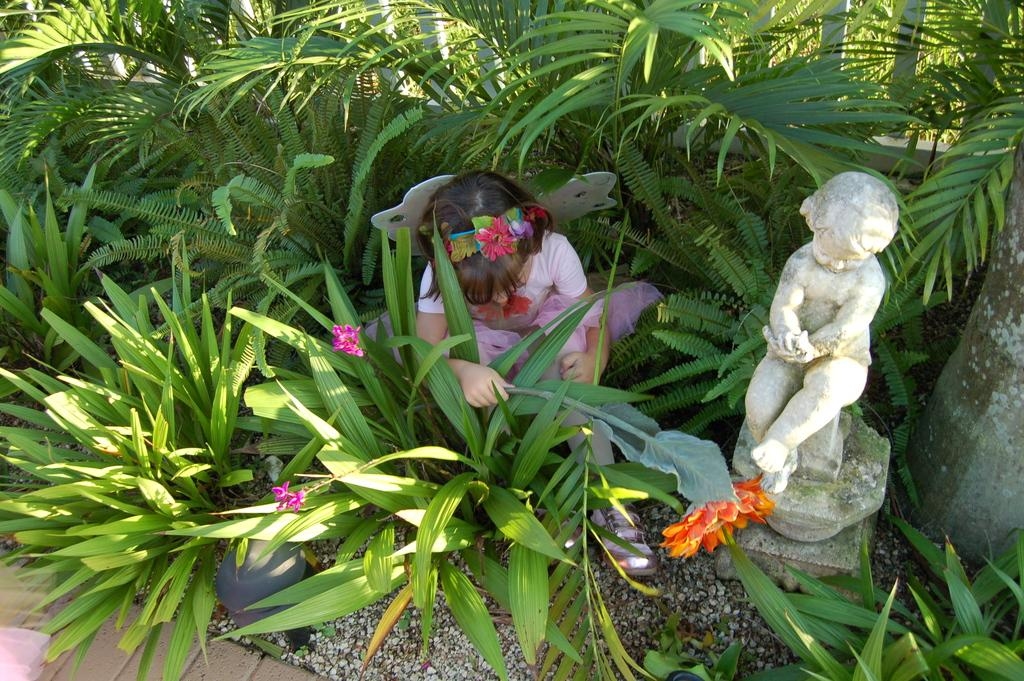What is the main subject in the image? There is a statue in the image. Are there any people in the image? Yes, there is a girl in the image. Where is the girl located in relation to the plants? The girl is between plants in the image. What type of structure can be seen in the image? There is a cement grill in the image. What else is present in the image besides the statue, girl, and plants? There is a pole and stones in the image. What type of cable is being used for the operation in the image? There is no operation or cable present in the image. 